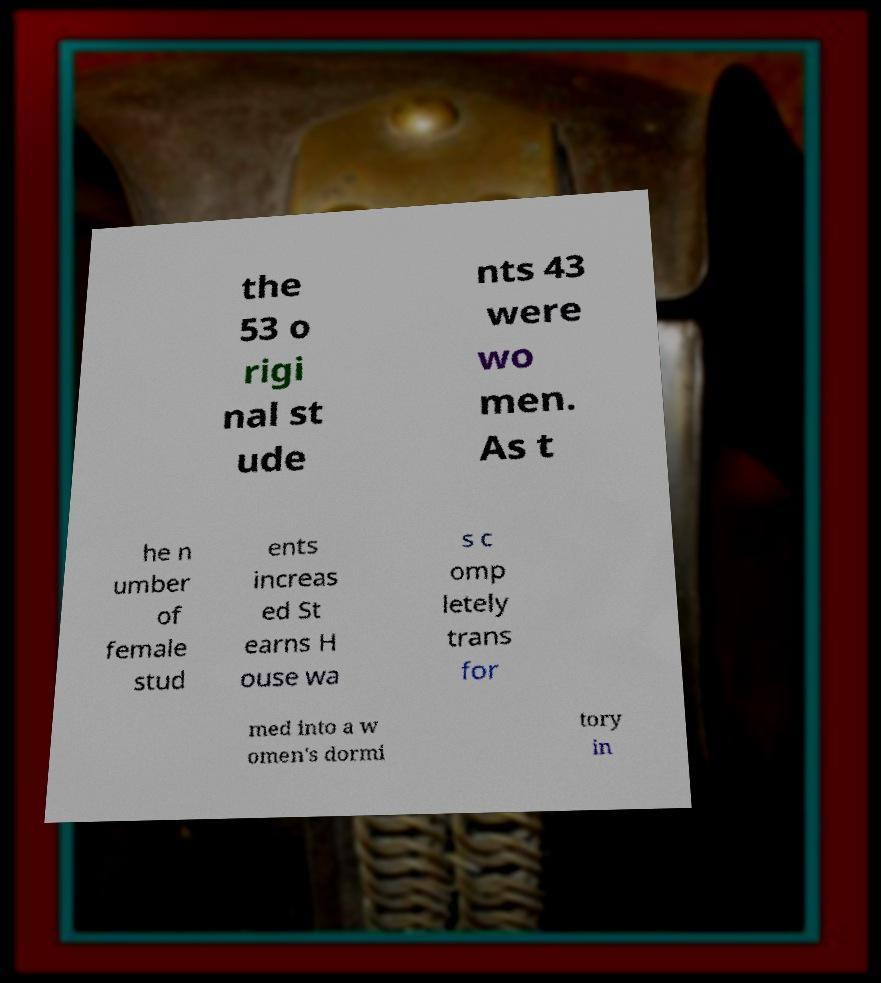Please read and relay the text visible in this image. What does it say? the 53 o rigi nal st ude nts 43 were wo men. As t he n umber of female stud ents increas ed St earns H ouse wa s c omp letely trans for med into a w omen's dormi tory in 